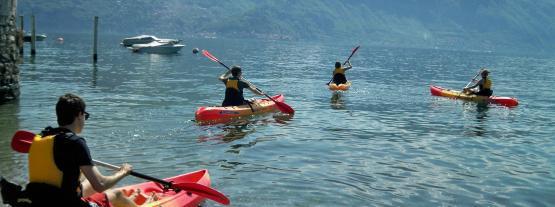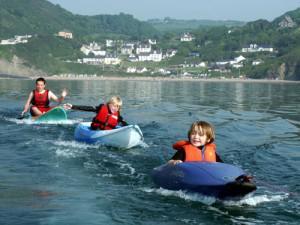The first image is the image on the left, the second image is the image on the right. Assess this claim about the two images: "There are people using red paddles.". Correct or not? Answer yes or no. Yes. The first image is the image on the left, the second image is the image on the right. For the images displayed, is the sentence "Multiple canoes are headed away from the camera in one image." factually correct? Answer yes or no. Yes. 